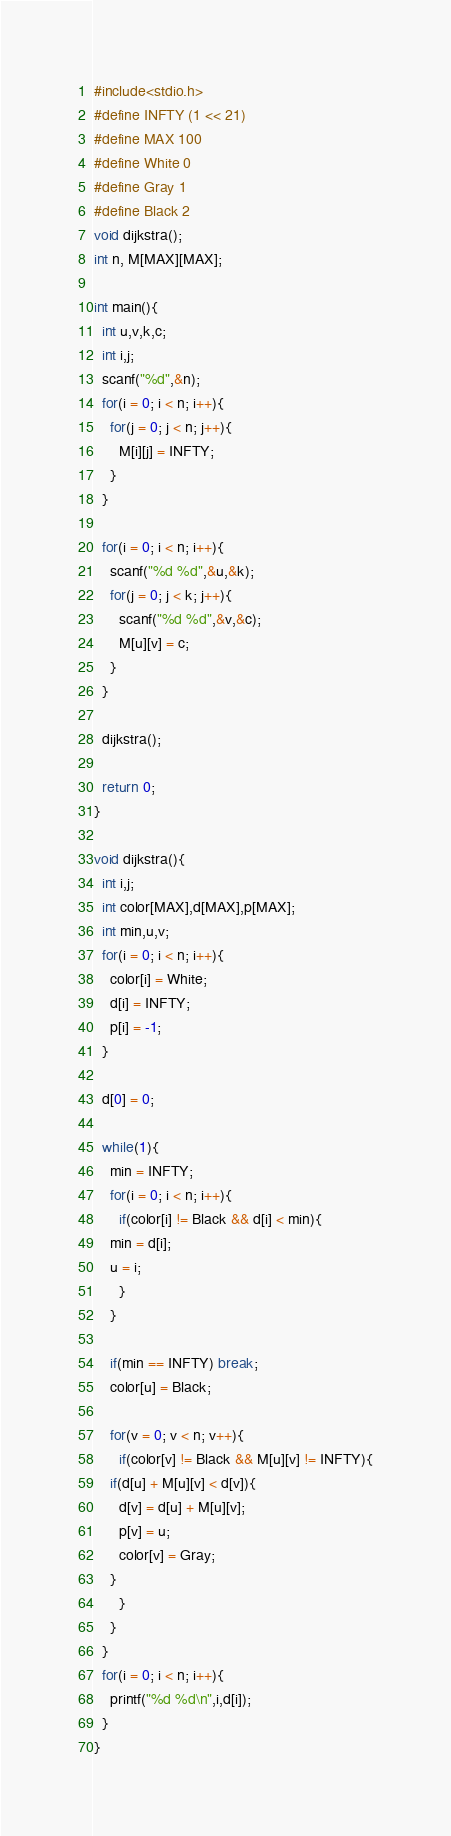<code> <loc_0><loc_0><loc_500><loc_500><_C_>#include<stdio.h>
#define INFTY (1 << 21)
#define MAX 100
#define White 0
#define Gray 1
#define Black 2
void dijkstra();
int n, M[MAX][MAX];

int main(){
  int u,v,k,c;
  int i,j;
  scanf("%d",&n);
  for(i = 0; i < n; i++){
    for(j = 0; j < n; j++){
      M[i][j] = INFTY;
    }
  }

  for(i = 0; i < n; i++){
    scanf("%d %d",&u,&k);
    for(j = 0; j < k; j++){
      scanf("%d %d",&v,&c);
      M[u][v] = c;
    }
  }

  dijkstra();

  return 0;
}

void dijkstra(){
  int i,j;
  int color[MAX],d[MAX],p[MAX];
  int min,u,v;
  for(i = 0; i < n; i++){
    color[i] = White;
    d[i] = INFTY;
    p[i] = -1;
  }

  d[0] = 0;

  while(1){
    min = INFTY;
    for(i = 0; i < n; i++){
      if(color[i] != Black && d[i] < min){
	min = d[i];
	u = i;
      }
    }

    if(min == INFTY) break;
    color[u] = Black;

    for(v = 0; v < n; v++){
      if(color[v] != Black && M[u][v] != INFTY){
	if(d[u] + M[u][v] < d[v]){
	  d[v] = d[u] + M[u][v];
	  p[v] = u;
	  color[v] = Gray;
	}
      }
    }
  }
  for(i = 0; i < n; i++){
    printf("%d %d\n",i,d[i]);
  }
}</code> 